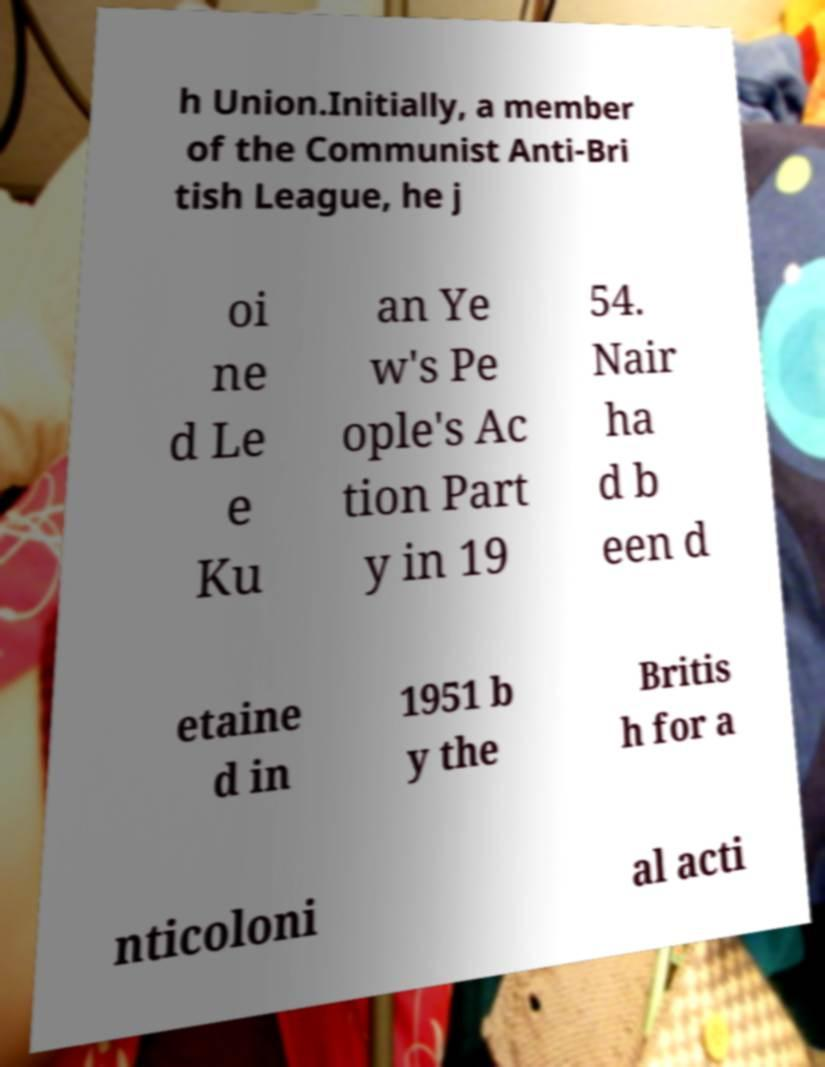Can you accurately transcribe the text from the provided image for me? h Union.Initially, a member of the Communist Anti-Bri tish League, he j oi ne d Le e Ku an Ye w's Pe ople's Ac tion Part y in 19 54. Nair ha d b een d etaine d in 1951 b y the Britis h for a nticoloni al acti 